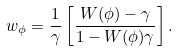<formula> <loc_0><loc_0><loc_500><loc_500>w _ { \phi } = \frac { 1 } { \gamma } \left [ \frac { W ( \phi ) - \gamma } { 1 - W ( \phi ) \gamma } \right ] .</formula> 